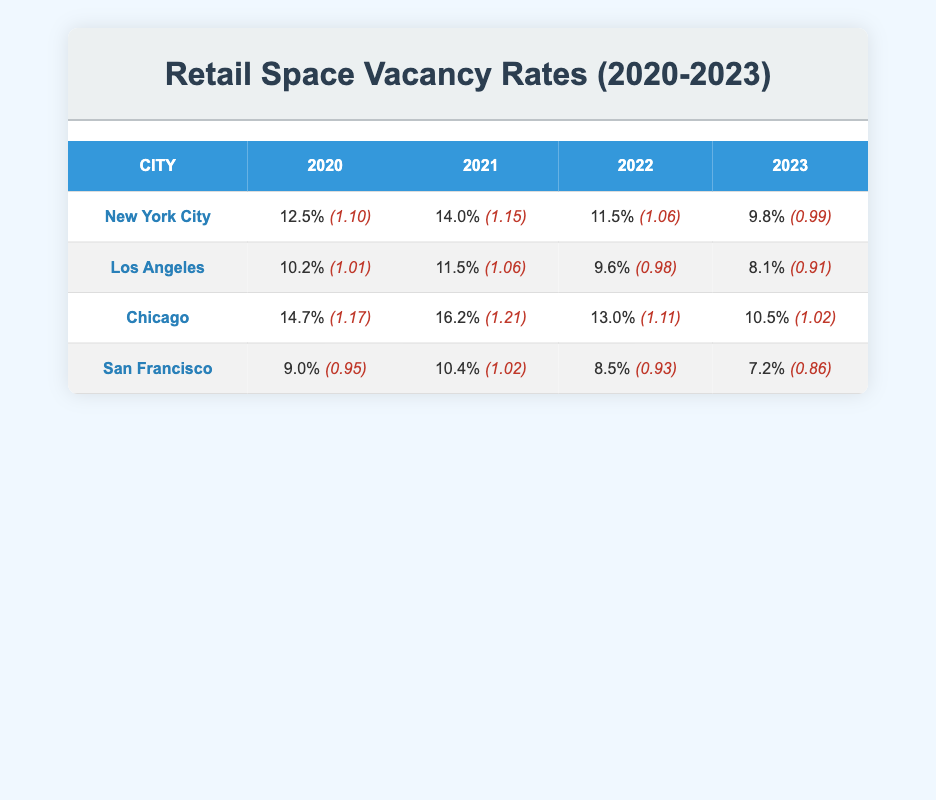What was the vacancy rate in New York City in 2022? In the table, looking under New York City for the year 2022, the vacancy rate is listed as 11.5%.
Answer: 11.5% Which city had the highest vacancy rate in 2021? By comparing the values for the year 2021 across all cities, New York City has a vacancy rate of 14.0%, which is higher than Los Angeles at 11.5%, Chicago at 16.2%, and San Francisco at 10.4%. Hence, Chicago had the highest at 16.2%.
Answer: Chicago What is the average vacancy rate for retail spaces in San Francisco from 2020 to 2023? To find the average, add the vacancy rates for San Francisco over the four years: (9.0 + 10.4 + 8.5 + 7.2) = 35.1, then divide by 4, giving 35.1 / 4 = 8.775%.
Answer: 8.775% Did any city reduce its vacancy rate every year from 2020 to 2023? Analyzing the data, Los Angeles' rates were 10.2% in 2020, 11.5% in 2021, 9.6% in 2022, and 8.1% in 2023. It did not reduce every year, showing an increase in 2021. The same goes for New York City and Chicago; they had fluctuations. However, San Francisco reduced its vacancy rate every year from 2020 to 2023.
Answer: Yes What was the change in vacancy rate for Chicago from 2020 to 2023? The vacancy rate for Chicago in 2020 was 14.7% and in 2023 it was 10.5%. To find the change, subtract the 2023 rate from the 2020 rate: 14.7% - 10.5% = 4.2%.
Answer: 4.2% 